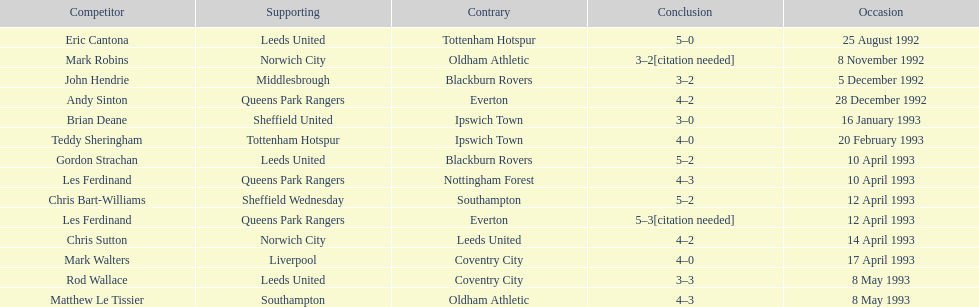How many players were for leeds united? 3. 